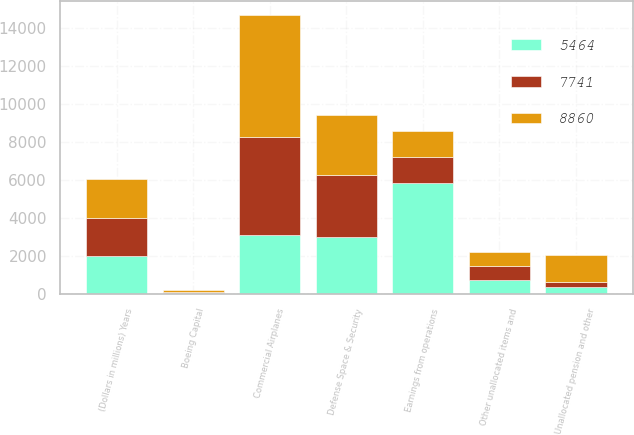<chart> <loc_0><loc_0><loc_500><loc_500><stacked_bar_chart><ecel><fcel>(Dollars in millions) Years<fcel>Commercial Airplanes<fcel>Defense Space & Security<fcel>Boeing Capital<fcel>Unallocated pension and other<fcel>Other unallocated items and<fcel>Earnings from operations<nl><fcel>5464<fcel>2016<fcel>3130<fcel>3008<fcel>59<fcel>370<fcel>733<fcel>5834<nl><fcel>7741<fcel>2015<fcel>5157<fcel>3274<fcel>50<fcel>298<fcel>740<fcel>1387<nl><fcel>8860<fcel>2014<fcel>6411<fcel>3133<fcel>92<fcel>1387<fcel>776<fcel>1387<nl></chart> 